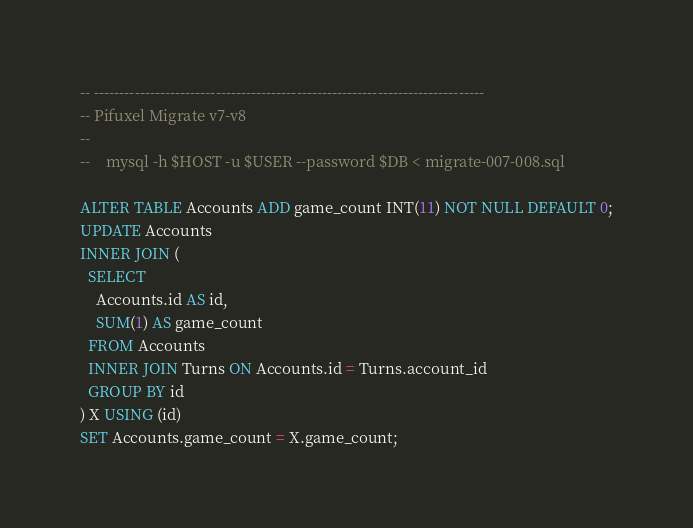Convert code to text. <code><loc_0><loc_0><loc_500><loc_500><_SQL_>-- -----------------------------------------------------------------------------
-- Pifuxel Migrate v7-v8
--
--    mysql -h $HOST -u $USER --password $DB < migrate-007-008.sql

ALTER TABLE Accounts ADD game_count INT(11) NOT NULL DEFAULT 0;
UPDATE Accounts
INNER JOIN (
  SELECT
    Accounts.id AS id,
    SUM(1) AS game_count
  FROM Accounts
  INNER JOIN Turns ON Accounts.id = Turns.account_id
  GROUP BY id
) X USING (id)
SET Accounts.game_count = X.game_count;
</code> 